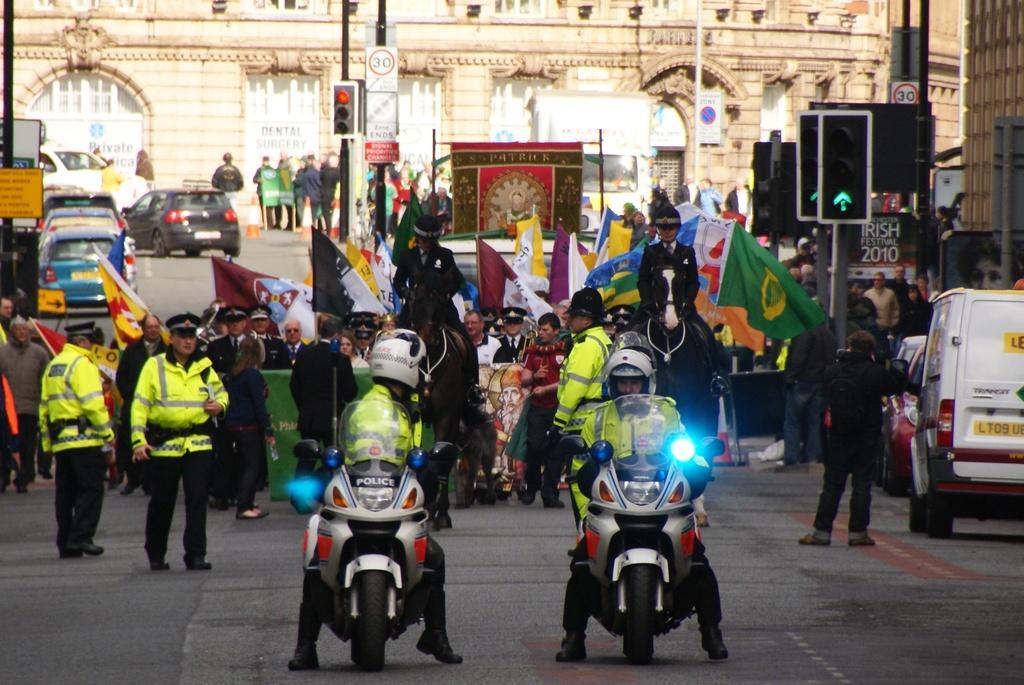Could you give a brief overview of what you see in this image? In this image, we can see two police bikes, there are two persons sitting on the bikes and they are wearing helmets, in the background there are some people standing, we can see some cars and there are some signal lights. 